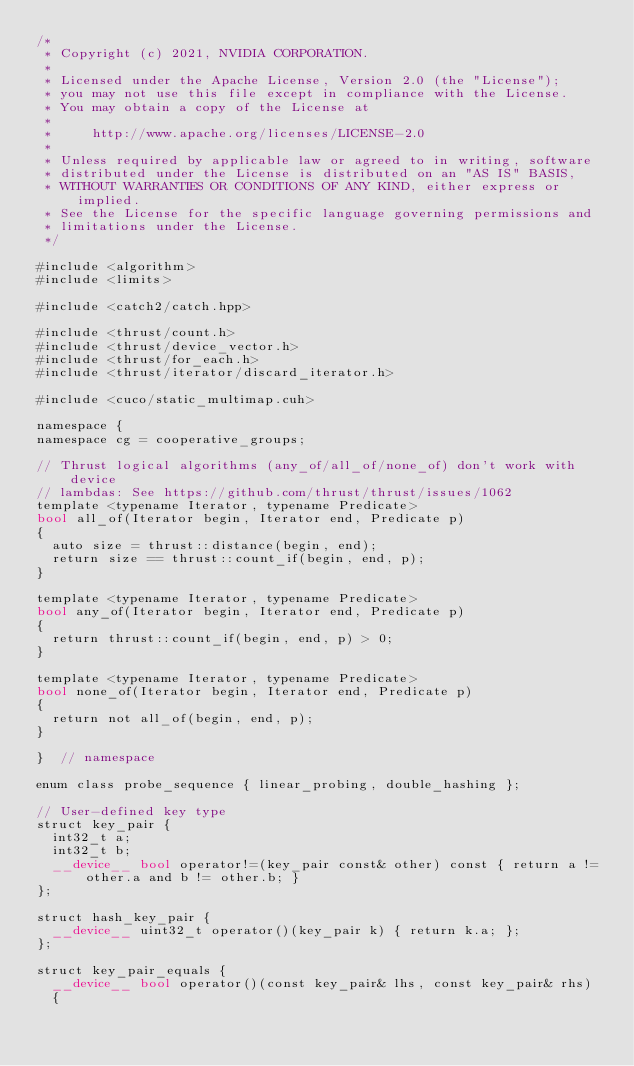<code> <loc_0><loc_0><loc_500><loc_500><_Cuda_>/*
 * Copyright (c) 2021, NVIDIA CORPORATION.
 *
 * Licensed under the Apache License, Version 2.0 (the "License");
 * you may not use this file except in compliance with the License.
 * You may obtain a copy of the License at
 *
 *     http://www.apache.org/licenses/LICENSE-2.0
 *
 * Unless required by applicable law or agreed to in writing, software
 * distributed under the License is distributed on an "AS IS" BASIS,
 * WITHOUT WARRANTIES OR CONDITIONS OF ANY KIND, either express or implied.
 * See the License for the specific language governing permissions and
 * limitations under the License.
 */

#include <algorithm>
#include <limits>

#include <catch2/catch.hpp>

#include <thrust/count.h>
#include <thrust/device_vector.h>
#include <thrust/for_each.h>
#include <thrust/iterator/discard_iterator.h>

#include <cuco/static_multimap.cuh>

namespace {
namespace cg = cooperative_groups;

// Thrust logical algorithms (any_of/all_of/none_of) don't work with device
// lambdas: See https://github.com/thrust/thrust/issues/1062
template <typename Iterator, typename Predicate>
bool all_of(Iterator begin, Iterator end, Predicate p)
{
  auto size = thrust::distance(begin, end);
  return size == thrust::count_if(begin, end, p);
}

template <typename Iterator, typename Predicate>
bool any_of(Iterator begin, Iterator end, Predicate p)
{
  return thrust::count_if(begin, end, p) > 0;
}

template <typename Iterator, typename Predicate>
bool none_of(Iterator begin, Iterator end, Predicate p)
{
  return not all_of(begin, end, p);
}

}  // namespace

enum class probe_sequence { linear_probing, double_hashing };

// User-defined key type
struct key_pair {
  int32_t a;
  int32_t b;
  __device__ bool operator!=(key_pair const& other) const { return a != other.a and b != other.b; }
};

struct hash_key_pair {
  __device__ uint32_t operator()(key_pair k) { return k.a; };
};

struct key_pair_equals {
  __device__ bool operator()(const key_pair& lhs, const key_pair& rhs)
  {</code> 